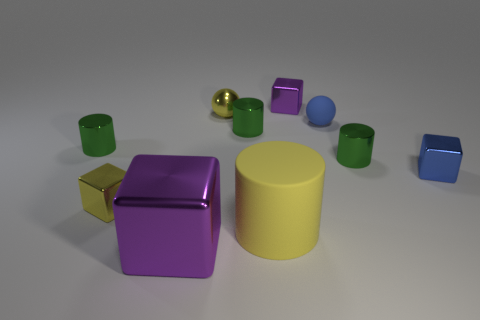Subtract all purple blocks. How many were subtracted if there are1purple blocks left? 1 Subtract all tiny blocks. How many blocks are left? 1 Subtract all cyan cylinders. How many purple cubes are left? 2 Subtract all yellow cylinders. How many cylinders are left? 3 Subtract all cylinders. How many objects are left? 6 Subtract 1 cylinders. How many cylinders are left? 3 Add 1 large purple metallic blocks. How many large purple metallic blocks are left? 2 Add 9 brown metallic spheres. How many brown metallic spheres exist? 9 Subtract 0 green cubes. How many objects are left? 10 Subtract all green balls. Subtract all gray cylinders. How many balls are left? 2 